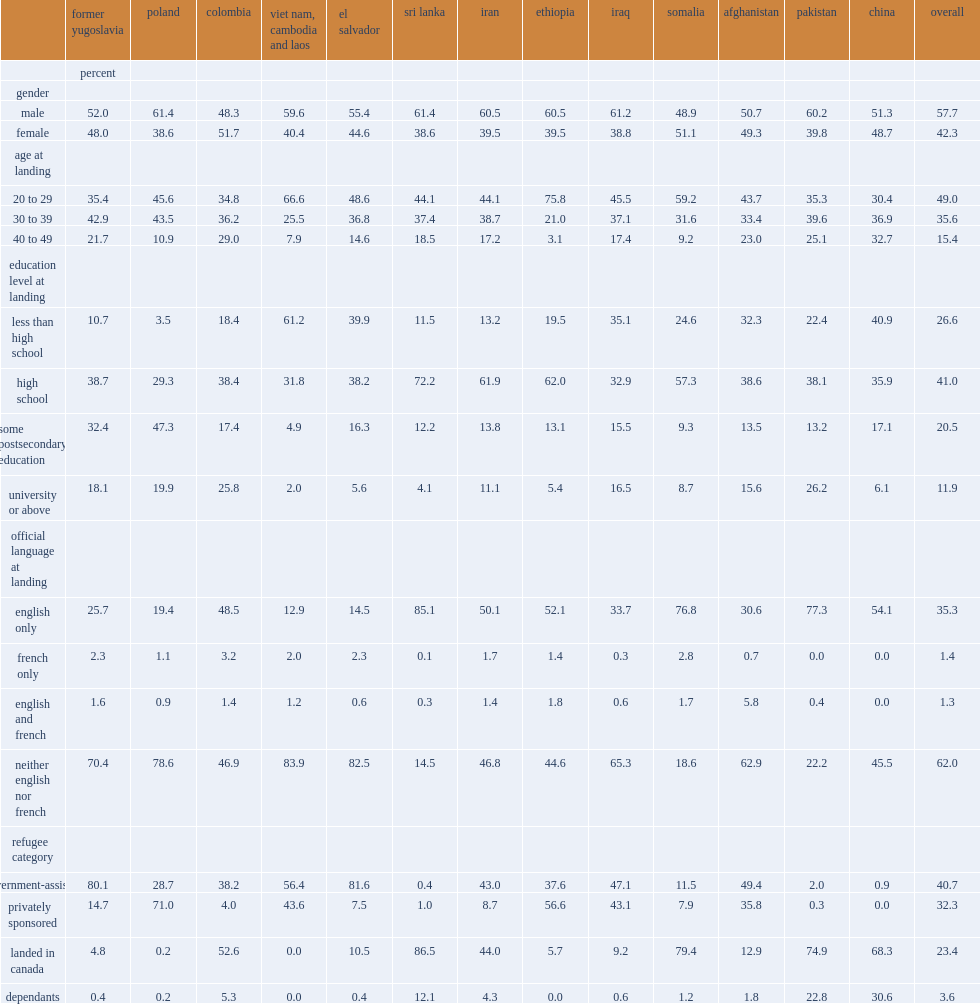What were the percentages of those from the former yugoslavia, poland, colombia and pakistan who had a university degree? 18.1 19.9 25.8. What was the percentage of refugees from the former yugoslavia who spoke neither english nor french at landing? 70.4. What was the percentage of those from sri lanka who speak english only? 85.1. 